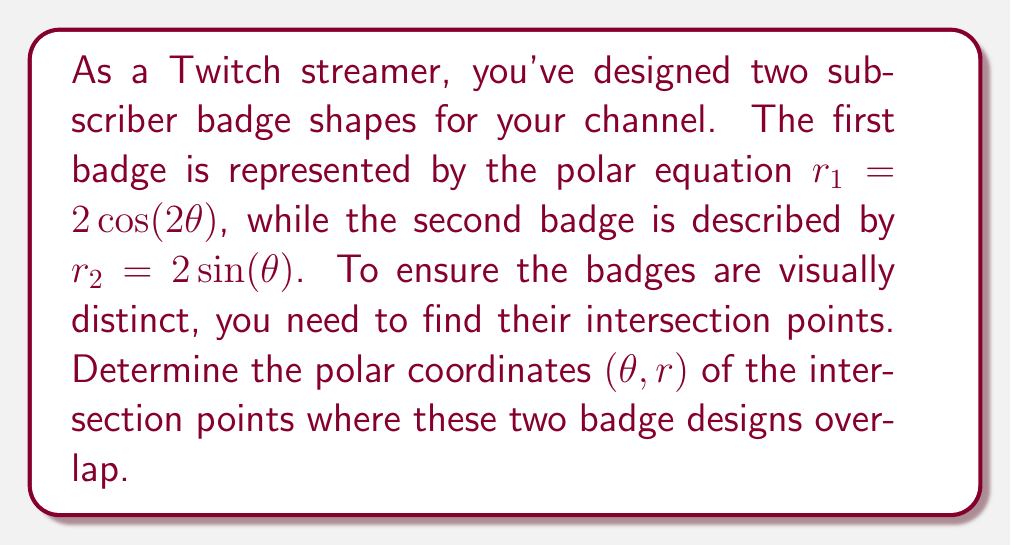Solve this math problem. To find the intersection points of the two badge designs, we need to solve the system of equations:

$$r_1 = 2\cos(2\theta)$$
$$r_2 = 2\sin(\theta)$$

At the intersection points, $r_1 = r_2$, so we can set the equations equal to each other:

$$2\cos(2\theta) = 2\sin(\theta)$$

Simplifying:

$$\cos(2\theta) = \sin(\theta)$$

Using the double angle formula for cosine, we can rewrite the left side:

$$\cos^2(\theta) - \sin^2(\theta) = \sin(\theta)$$

Rearranging terms:

$$\cos^2(\theta) - \sin^2(\theta) - \sin(\theta) = 0$$

Let $u = \sin(\theta)$. Then $\cos^2(\theta) = 1 - u^2$. Substituting:

$$(1 - u^2) - u^2 - u = 0$$
$$1 - 2u^2 - u = 0$$

This is a quadratic equation in $u$. Rearranging:

$$2u^2 + u - 1 = 0$$

Using the quadratic formula, $u = \frac{-b \pm \sqrt{b^2 - 4ac}}{2a}$:

$$u = \frac{-1 \pm \sqrt{1^2 - 4(2)(-1)}}{2(2)} = \frac{-1 \pm \sqrt{9}}{4} = \frac{-1 \pm 3}{4}$$

This gives us two solutions for $u$:

$$u_1 = \frac{1}{2} \text{ and } u_2 = -\frac{1}{2}$$

Recall that $u = \sin(\theta)$, so:

$$\theta_1 = \arcsin(\frac{1}{2}) = \frac{\pi}{6} \text{ or } \frac{5\pi}{6}$$
$$\theta_2 = \arcsin(-\frac{1}{2}) = -\frac{\pi}{6} \text{ or } \frac{7\pi}{6}$$

To find the corresponding $r$ values, we can use either of the original equations. Let's use $r = 2\sin(\theta)$:

For $\theta = \frac{\pi}{6}$ or $\frac{5\pi}{6}$: $r = 2\sin(\frac{\pi}{6}) = 1$
For $\theta = -\frac{\pi}{6}$ or $\frac{7\pi}{6}$: $r = 2\sin(-\frac{\pi}{6}) = -1$

Therefore, the intersection points are:

$$(\frac{\pi}{6}, 1), (\frac{5\pi}{6}, 1), (-\frac{\pi}{6}, -1), \text{ and } (\frac{7\pi}{6}, -1)$$
Answer: The intersection points of the two Twitch subscriber badge designs are:
$$(\frac{\pi}{6}, 1), (\frac{5\pi}{6}, 1), (-\frac{\pi}{6}, -1), \text{ and } (\frac{7\pi}{6}, -1)$$ 